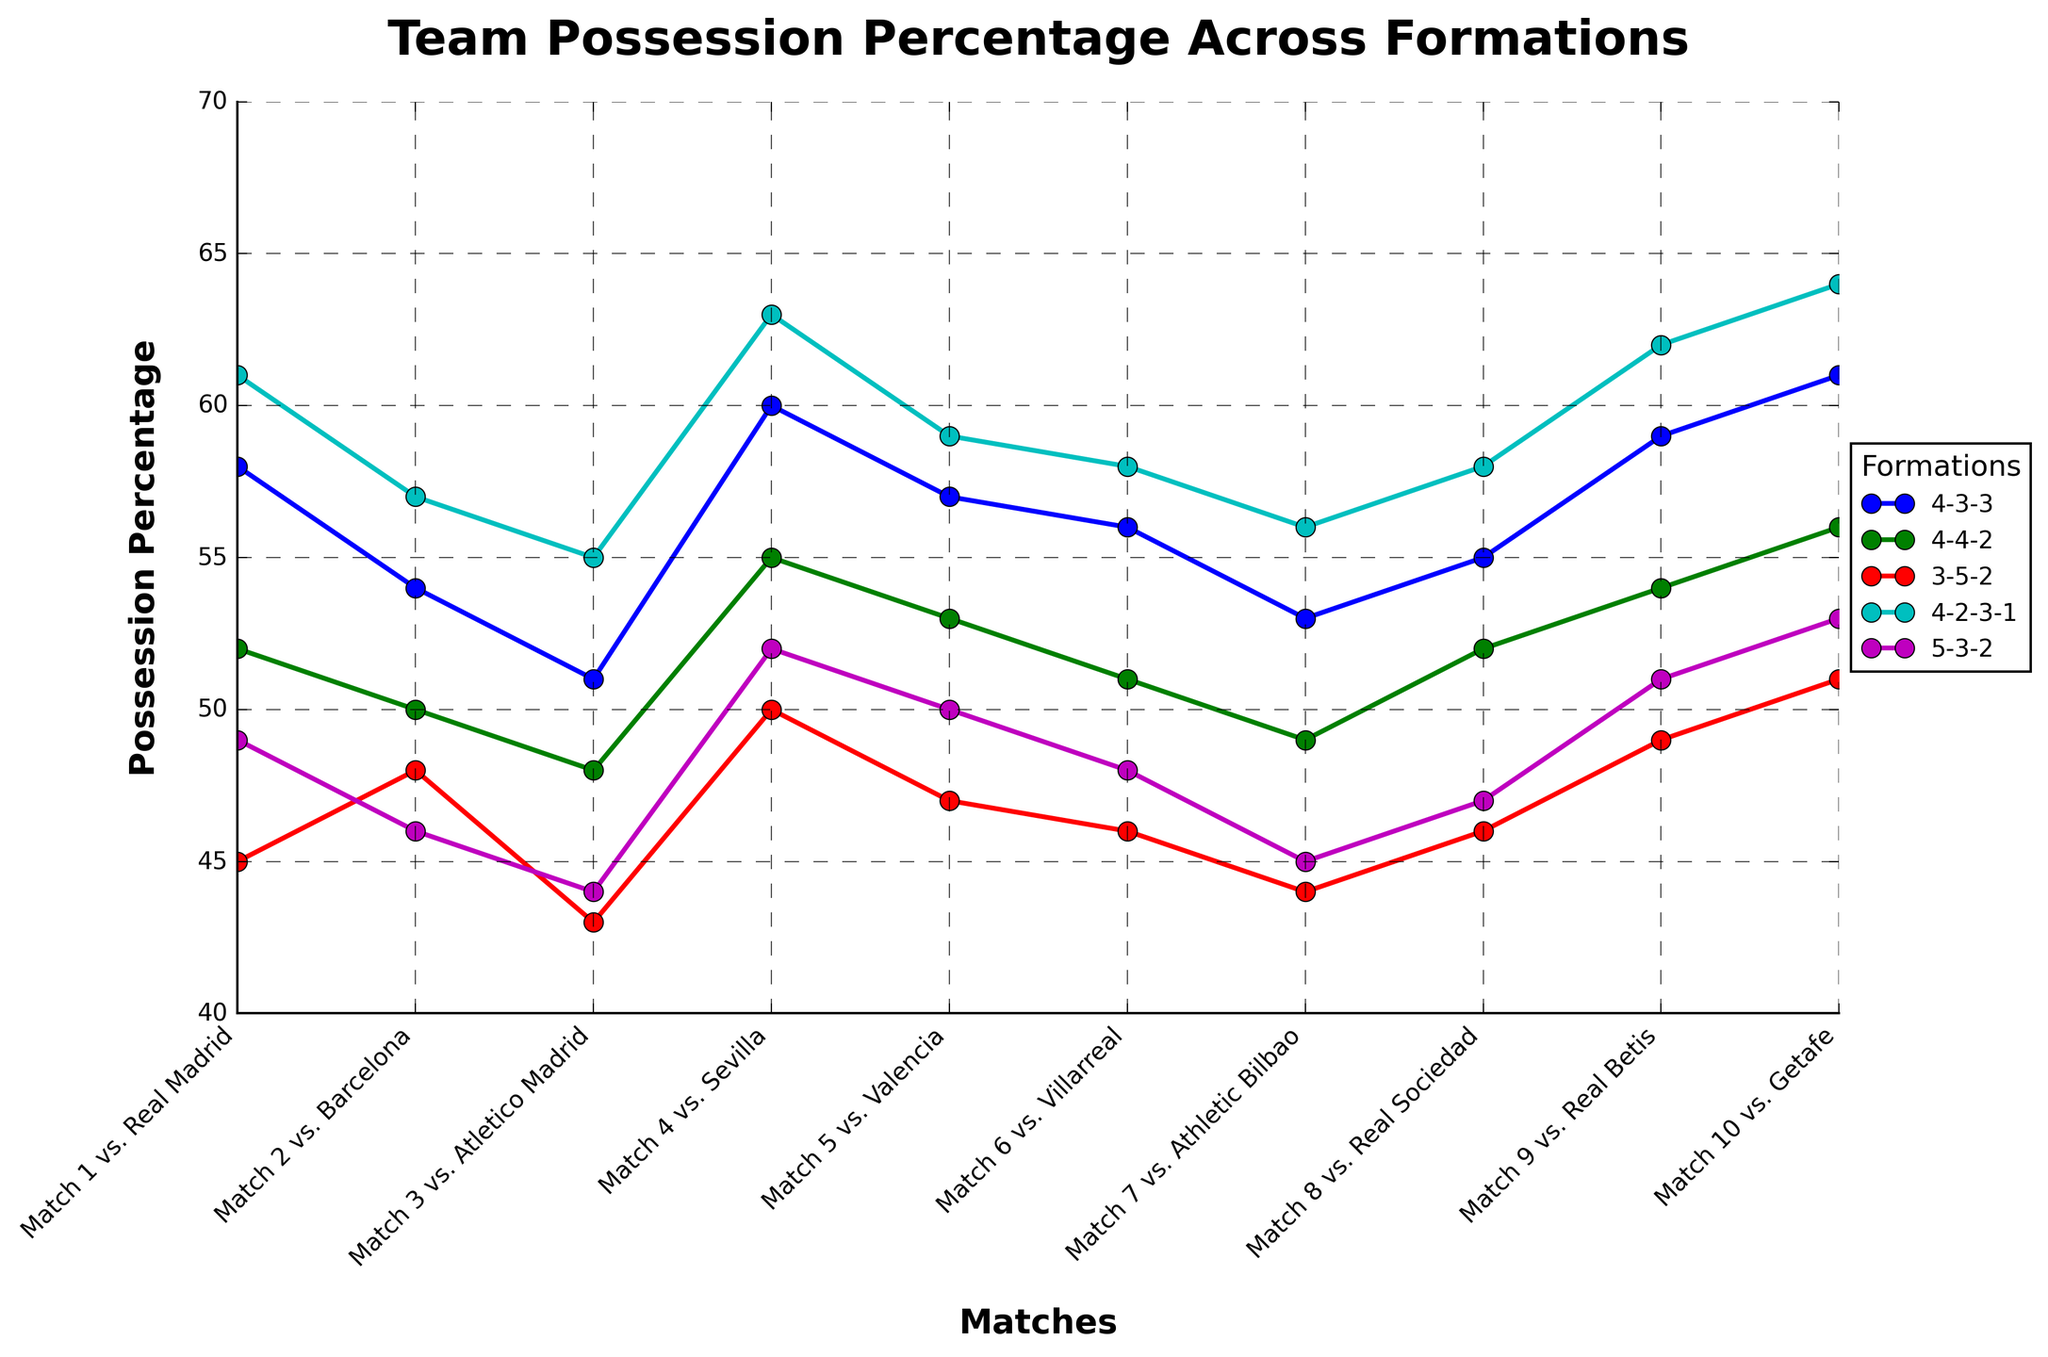What's the average possession percentage for the 4-3-3 formation? To find the average possession percentage for the 4-3-3 formation, sum up all the possession percentages (58 + 54 + 51 + 60 + 57 + 56 + 53 + 55 + 59 + 61) which equals 564, and divide by the number of matches (10). The average possession percentage is 564/10.
Answer: 56.4 Which formation had the highest possession percentage in the match against Sevilla? Look at the data points for the match against Sevilla for each formation. The values are: 4-3-3 (60%), 4-4-2 (55%), 3-5-2 (50%), 4-2-3-1 (63%), and 5-3-2 (52%). The highest value is for the 4-2-3-1 formation.
Answer: 4-2-3-1 What's the difference in possession percentage between the 4-4-2 and 5-3-2 formations in the match against Valencia? For Valencia, the possession percentage for 4-4-2 is 53% and for 5-3-2, it is 50%. The difference is 53 - 50.
Answer: 3% Which formation shows the most consistent possession percentage across all matches? To find the most consistent formation, we need to look at the ranges for each formation's possession percentages. The ranges for each are:
  - 4-3-3: 61 - 51 = 10
  - 4-4-2: 56 - 48 = 8 
  - 3-5-2: 51 - 43 = 8 
  - 4-2-3-1: 64 - 55 = 9 
  - 5-3-2: 53 - 44 = 9 
The smallest range is for the 4-4-2 and 3-5-2 formations.
Answer: 4-4-2 and 3-5-2 What is the median possession percentage for the 4-2-3-1 formation? Arrange the possession percentages for 4-2-3-1 in increasing order and find the middle value. The values are: 55, 56, 57, 58, 58, 59, 61, 62, 63, 64. The median is the average of the 5th and 6th values (58 and 59). (58 + 59)/2 = 58.5.
Answer: 58.5 By how much did the possession percentage for the 3-5-2 formation in the match against Getafe exceed the possession percentage for the same formation in the match against Atletico Madrid? The possession percentage for 3-5-2 against Getafe is 51%. Against Atletico Madrid, it is 43%. The difference is 51 - 43.
Answer: 8% Which formation had the lowest possession percentage in the match against Real Madrid? Look at the data points for the match against Real Madrid for each formation. The values are: 4-3-3 (58%), 4-4-2 (52%), 3-5-2 (45%), 4-2-3-1 (61%), and 5-3-2 (49%). The lowest value is for the 3-5-2 formation.
Answer: 3-5-2 Which formation showed an increase in possession percentage in each successive match? Check each formation for an increasing trend across successive matches. No formation consistently increases possession percentage for every match (each has fluctuations).
Answer: None How does the possession percentage for the 5-3-2 formation in the match against Villareal compare visually to the 4-3-3 formation in the same match? Visually inspect the plot for possession percentages in the match against Villarreal. The 4-3-3 formation has a higher data point (56%) compared to the 5-3-2 formation (48%). 4-3-3 is visually higher.
Answer: 4-3-3 What's the total possession percentage summed over all matches for the 4-4-2 formation? Sum up the possession percentages for 4-4-2 across all matches (52 + 50 + 48 + 55 + 53 + 51 + 49 + 52 + 54 + 56). The total is 520.
Answer: 520 